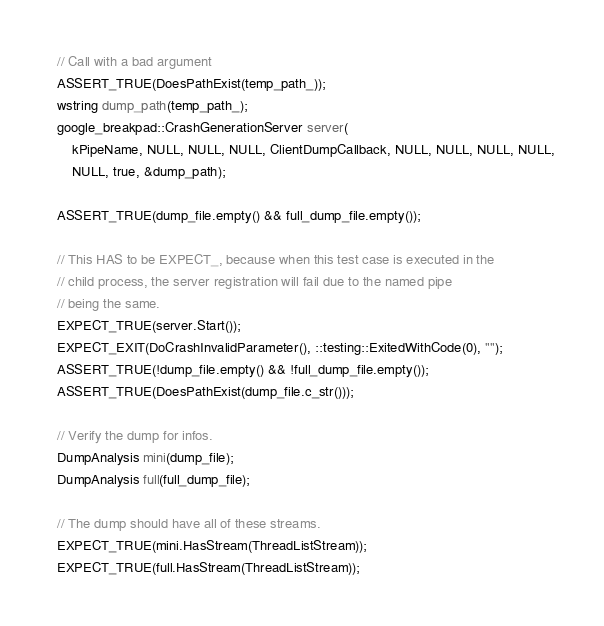Convert code to text. <code><loc_0><loc_0><loc_500><loc_500><_C++_>
  // Call with a bad argument
  ASSERT_TRUE(DoesPathExist(temp_path_));
  wstring dump_path(temp_path_);
  google_breakpad::CrashGenerationServer server(
      kPipeName, NULL, NULL, NULL, ClientDumpCallback, NULL, NULL, NULL, NULL,
      NULL, true, &dump_path);

  ASSERT_TRUE(dump_file.empty() && full_dump_file.empty());

  // This HAS to be EXPECT_, because when this test case is executed in the
  // child process, the server registration will fail due to the named pipe
  // being the same.
  EXPECT_TRUE(server.Start());
  EXPECT_EXIT(DoCrashInvalidParameter(), ::testing::ExitedWithCode(0), "");
  ASSERT_TRUE(!dump_file.empty() && !full_dump_file.empty());
  ASSERT_TRUE(DoesPathExist(dump_file.c_str()));

  // Verify the dump for infos.
  DumpAnalysis mini(dump_file);
  DumpAnalysis full(full_dump_file);

  // The dump should have all of these streams.
  EXPECT_TRUE(mini.HasStream(ThreadListStream));
  EXPECT_TRUE(full.HasStream(ThreadListStream));</code> 